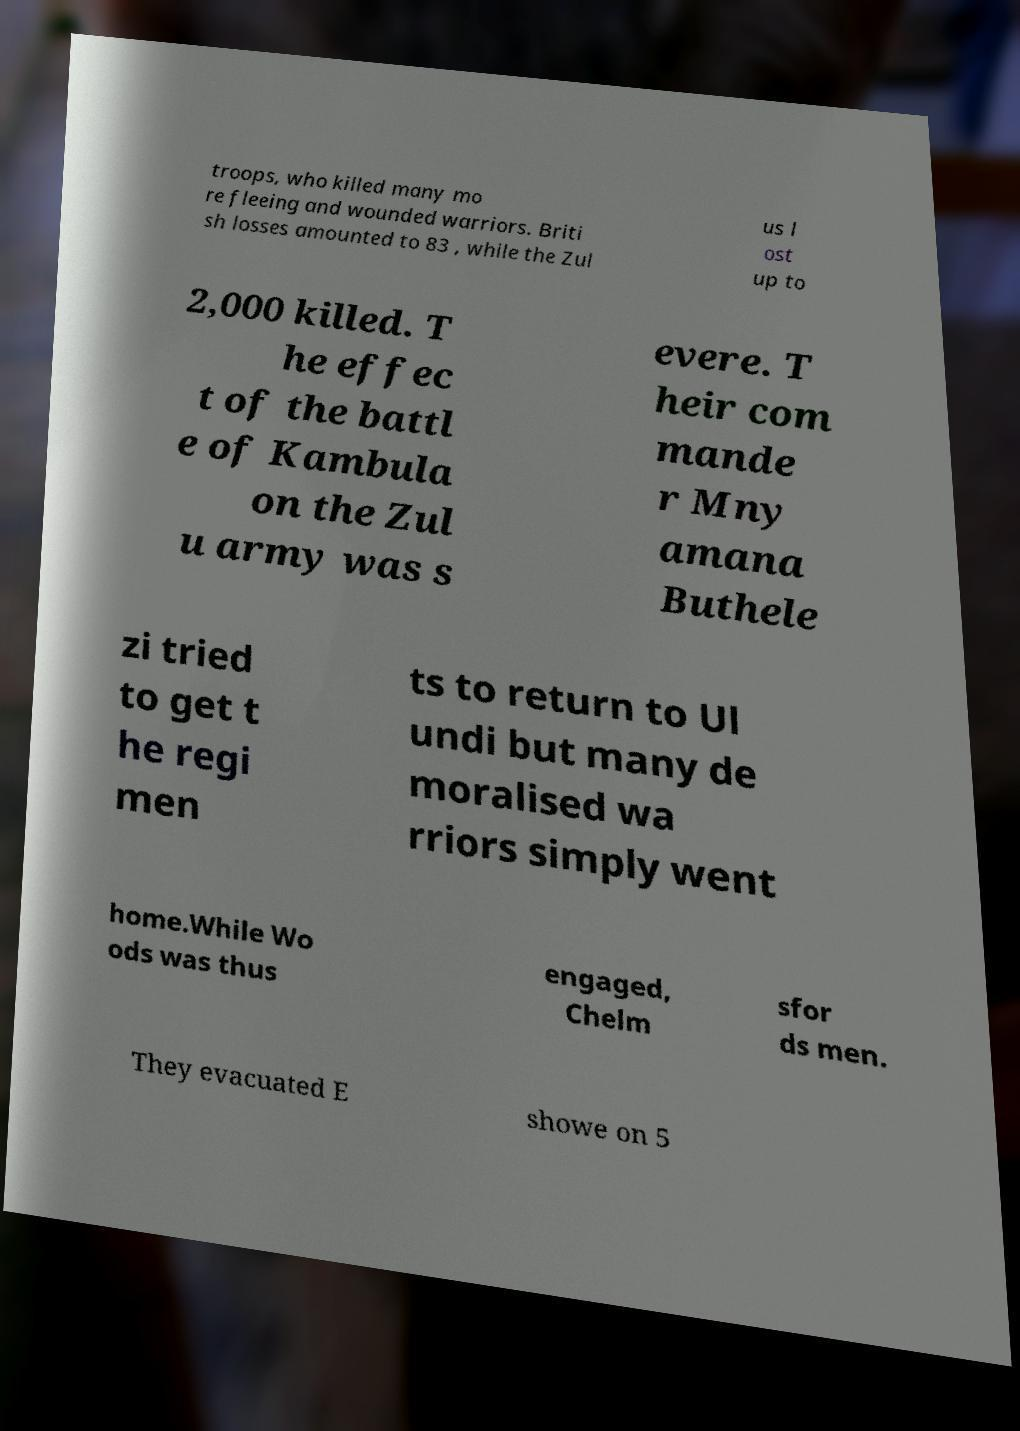There's text embedded in this image that I need extracted. Can you transcribe it verbatim? troops, who killed many mo re fleeing and wounded warriors. Briti sh losses amounted to 83 , while the Zul us l ost up to 2,000 killed. T he effec t of the battl e of Kambula on the Zul u army was s evere. T heir com mande r Mny amana Buthele zi tried to get t he regi men ts to return to Ul undi but many de moralised wa rriors simply went home.While Wo ods was thus engaged, Chelm sfor ds men. They evacuated E showe on 5 